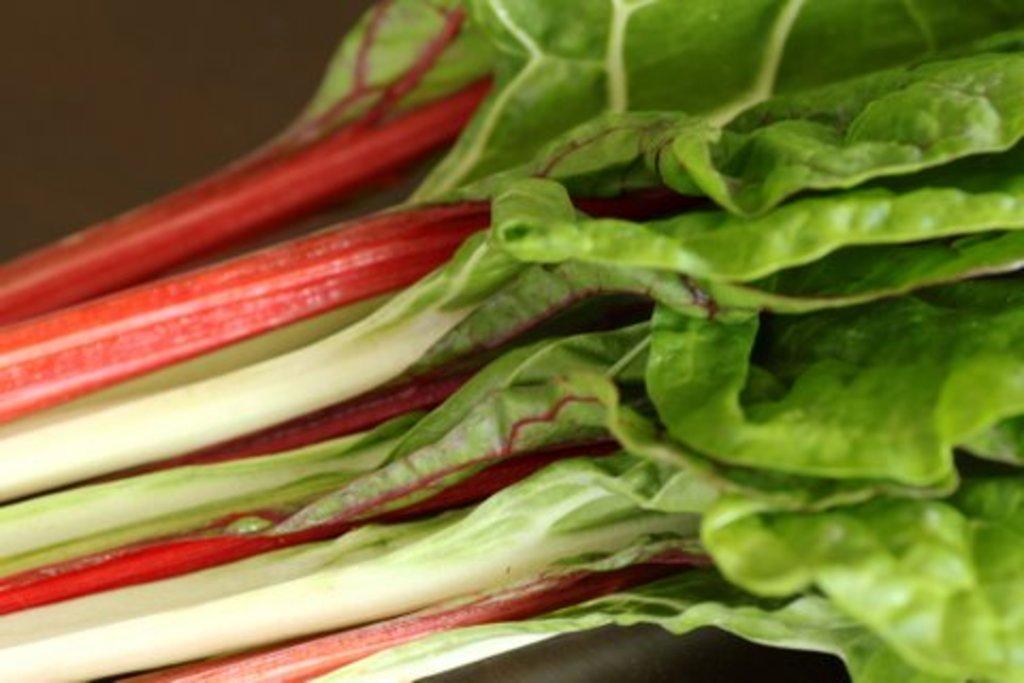In one or two sentences, can you explain what this image depicts? In this image I can see few green colour leaves. 